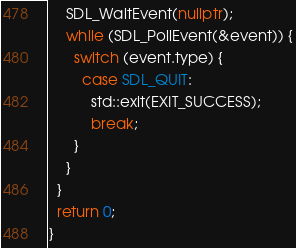<code> <loc_0><loc_0><loc_500><loc_500><_C++_>    SDL_WaitEvent(nullptr);
    while (SDL_PollEvent(&event)) {
      switch (event.type) {
        case SDL_QUIT:
          std::exit(EXIT_SUCCESS);
          break;
      }
    }
  }
  return 0;
}
</code> 